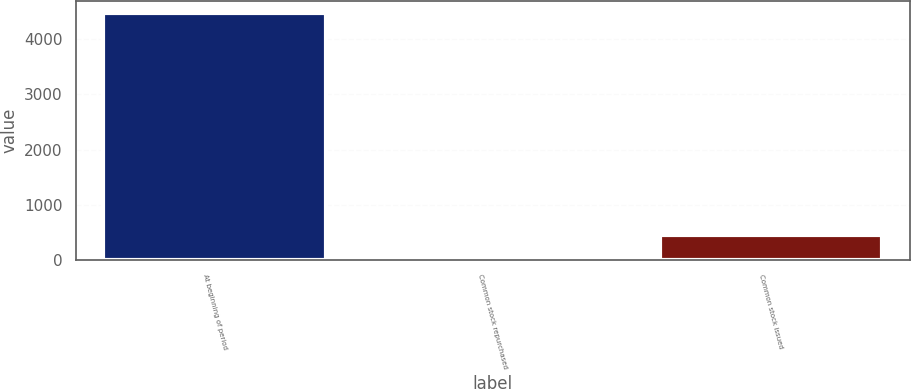Convert chart to OTSL. <chart><loc_0><loc_0><loc_500><loc_500><bar_chart><fcel>At beginning of period<fcel>Common stock repurchased<fcel>Common stock issued<nl><fcel>4468<fcel>5<fcel>451.3<nl></chart> 